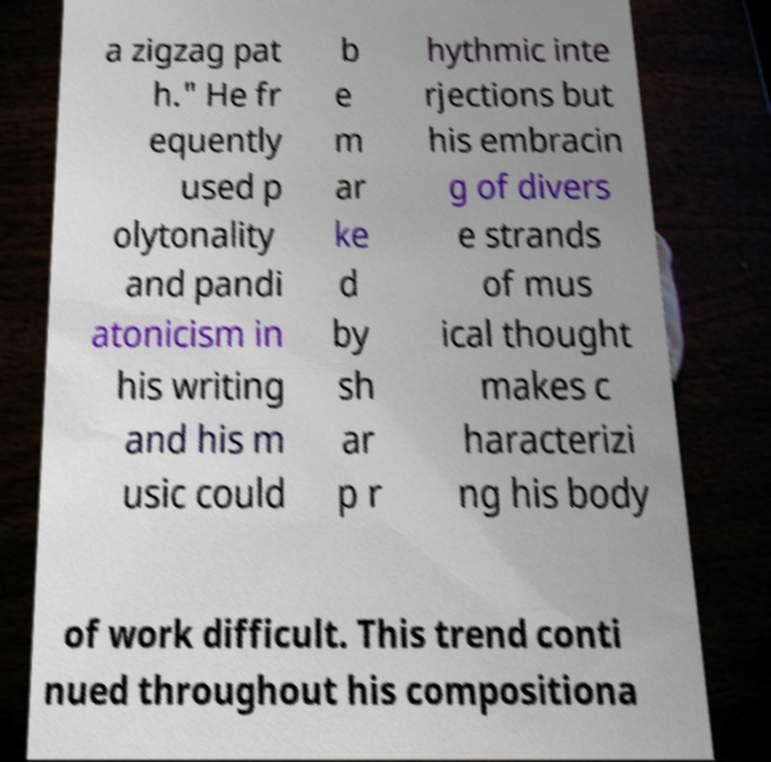Could you extract and type out the text from this image? a zigzag pat h." He fr equently used p olytonality and pandi atonicism in his writing and his m usic could b e m ar ke d by sh ar p r hythmic inte rjections but his embracin g of divers e strands of mus ical thought makes c haracterizi ng his body of work difficult. This trend conti nued throughout his compositiona 